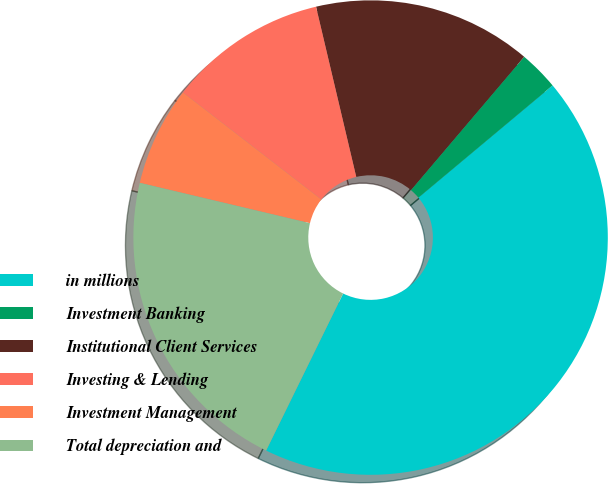Convert chart. <chart><loc_0><loc_0><loc_500><loc_500><pie_chart><fcel>in millions<fcel>Investment Banking<fcel>Institutional Client Services<fcel>Investing & Lending<fcel>Investment Management<fcel>Total depreciation and<nl><fcel>43.34%<fcel>2.71%<fcel>14.9%<fcel>10.83%<fcel>6.77%<fcel>21.45%<nl></chart> 